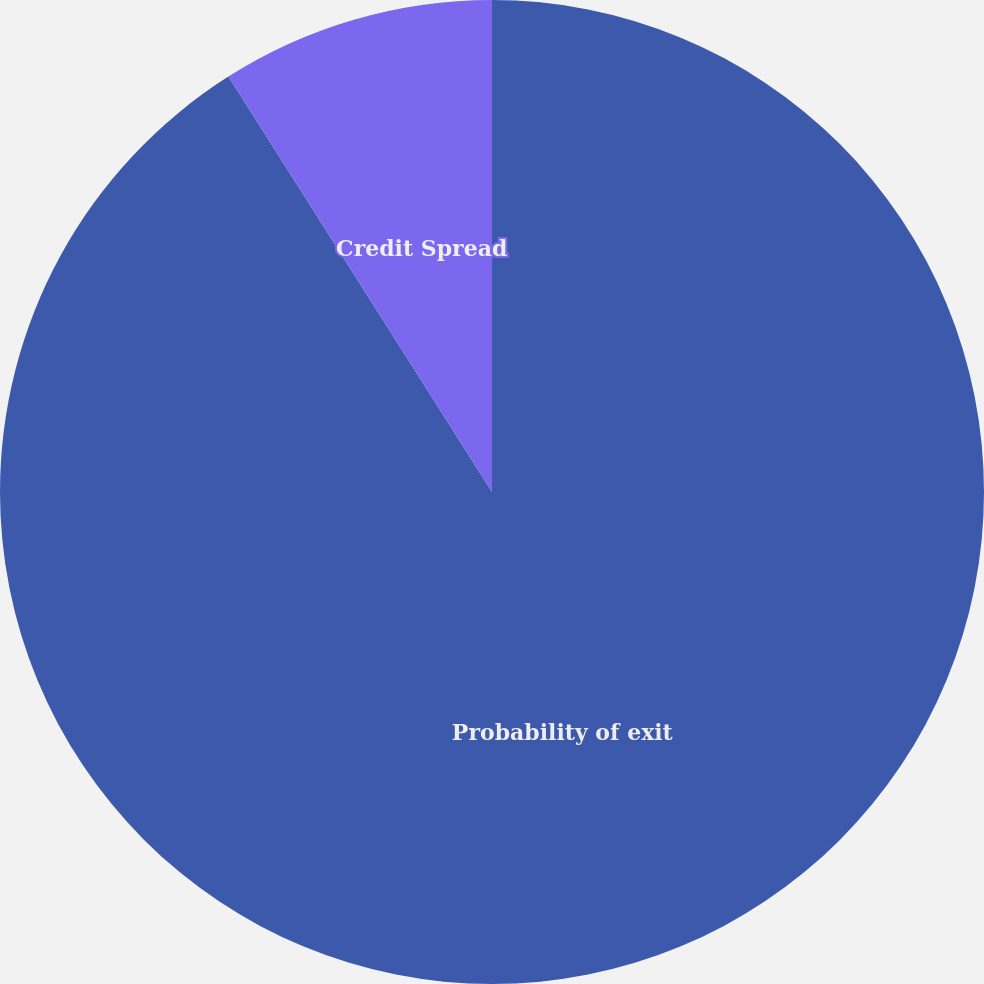<chart> <loc_0><loc_0><loc_500><loc_500><pie_chart><fcel>Probability of exit<fcel>Credit Spread<nl><fcel>91.0%<fcel>9.0%<nl></chart> 